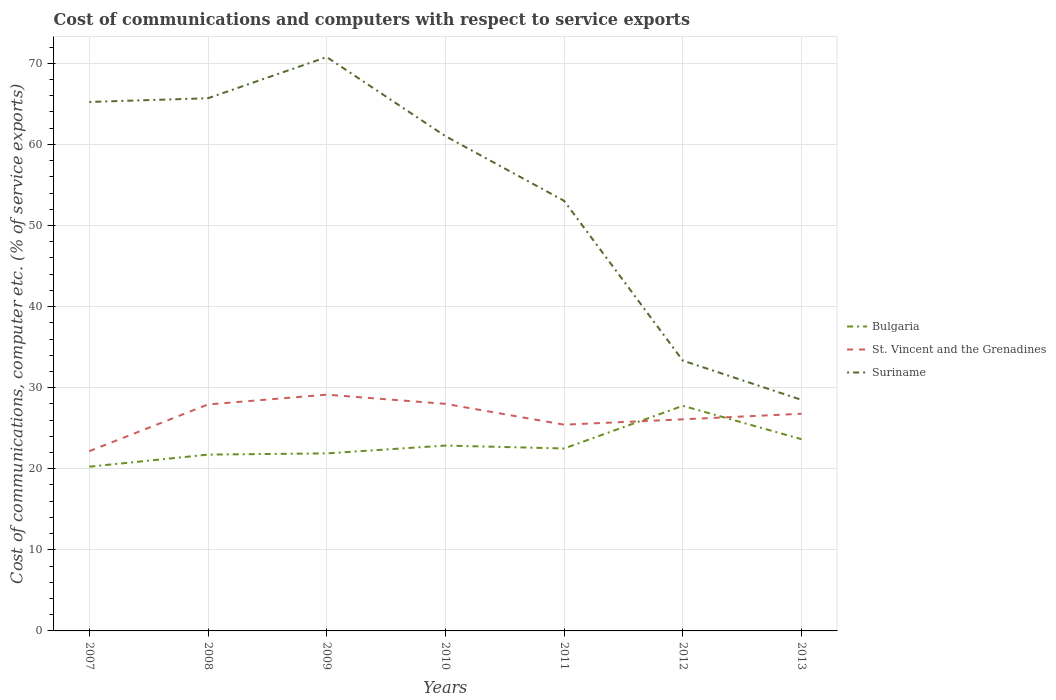How many different coloured lines are there?
Offer a very short reply. 3. Is the number of lines equal to the number of legend labels?
Make the answer very short. Yes. Across all years, what is the maximum cost of communications and computers in Suriname?
Your answer should be compact. 28.5. In which year was the cost of communications and computers in St. Vincent and the Grenadines maximum?
Your response must be concise. 2007. What is the total cost of communications and computers in St. Vincent and the Grenadines in the graph?
Offer a terse response. -5.83. What is the difference between the highest and the second highest cost of communications and computers in Suriname?
Ensure brevity in your answer.  42.27. What is the difference between the highest and the lowest cost of communications and computers in Suriname?
Give a very brief answer. 4. How many lines are there?
Your answer should be compact. 3. What is the difference between two consecutive major ticks on the Y-axis?
Your answer should be compact. 10. Where does the legend appear in the graph?
Provide a succinct answer. Center right. How many legend labels are there?
Offer a terse response. 3. What is the title of the graph?
Make the answer very short. Cost of communications and computers with respect to service exports. What is the label or title of the Y-axis?
Your answer should be compact. Cost of communications, computer etc. (% of service exports). What is the Cost of communications, computer etc. (% of service exports) of Bulgaria in 2007?
Your answer should be very brief. 20.25. What is the Cost of communications, computer etc. (% of service exports) of St. Vincent and the Grenadines in 2007?
Your response must be concise. 22.17. What is the Cost of communications, computer etc. (% of service exports) in Suriname in 2007?
Ensure brevity in your answer.  65.23. What is the Cost of communications, computer etc. (% of service exports) of Bulgaria in 2008?
Keep it short and to the point. 21.74. What is the Cost of communications, computer etc. (% of service exports) in St. Vincent and the Grenadines in 2008?
Keep it short and to the point. 27.93. What is the Cost of communications, computer etc. (% of service exports) of Suriname in 2008?
Your answer should be compact. 65.69. What is the Cost of communications, computer etc. (% of service exports) of Bulgaria in 2009?
Your answer should be compact. 21.89. What is the Cost of communications, computer etc. (% of service exports) in St. Vincent and the Grenadines in 2009?
Offer a very short reply. 29.14. What is the Cost of communications, computer etc. (% of service exports) of Suriname in 2009?
Your answer should be compact. 70.77. What is the Cost of communications, computer etc. (% of service exports) in Bulgaria in 2010?
Your answer should be compact. 22.86. What is the Cost of communications, computer etc. (% of service exports) in St. Vincent and the Grenadines in 2010?
Provide a succinct answer. 28. What is the Cost of communications, computer etc. (% of service exports) of Suriname in 2010?
Your response must be concise. 61.02. What is the Cost of communications, computer etc. (% of service exports) in Bulgaria in 2011?
Your response must be concise. 22.5. What is the Cost of communications, computer etc. (% of service exports) in St. Vincent and the Grenadines in 2011?
Ensure brevity in your answer.  25.43. What is the Cost of communications, computer etc. (% of service exports) of Suriname in 2011?
Your answer should be compact. 53.04. What is the Cost of communications, computer etc. (% of service exports) in Bulgaria in 2012?
Keep it short and to the point. 27.76. What is the Cost of communications, computer etc. (% of service exports) in St. Vincent and the Grenadines in 2012?
Provide a short and direct response. 26.09. What is the Cost of communications, computer etc. (% of service exports) in Suriname in 2012?
Your answer should be compact. 33.34. What is the Cost of communications, computer etc. (% of service exports) of Bulgaria in 2013?
Ensure brevity in your answer.  23.65. What is the Cost of communications, computer etc. (% of service exports) in St. Vincent and the Grenadines in 2013?
Provide a succinct answer. 26.78. What is the Cost of communications, computer etc. (% of service exports) of Suriname in 2013?
Provide a short and direct response. 28.5. Across all years, what is the maximum Cost of communications, computer etc. (% of service exports) of Bulgaria?
Offer a very short reply. 27.76. Across all years, what is the maximum Cost of communications, computer etc. (% of service exports) of St. Vincent and the Grenadines?
Provide a short and direct response. 29.14. Across all years, what is the maximum Cost of communications, computer etc. (% of service exports) of Suriname?
Provide a succinct answer. 70.77. Across all years, what is the minimum Cost of communications, computer etc. (% of service exports) of Bulgaria?
Offer a very short reply. 20.25. Across all years, what is the minimum Cost of communications, computer etc. (% of service exports) in St. Vincent and the Grenadines?
Provide a short and direct response. 22.17. Across all years, what is the minimum Cost of communications, computer etc. (% of service exports) of Suriname?
Your response must be concise. 28.5. What is the total Cost of communications, computer etc. (% of service exports) in Bulgaria in the graph?
Provide a succinct answer. 160.66. What is the total Cost of communications, computer etc. (% of service exports) of St. Vincent and the Grenadines in the graph?
Your answer should be very brief. 185.55. What is the total Cost of communications, computer etc. (% of service exports) in Suriname in the graph?
Keep it short and to the point. 377.59. What is the difference between the Cost of communications, computer etc. (% of service exports) of Bulgaria in 2007 and that in 2008?
Your response must be concise. -1.49. What is the difference between the Cost of communications, computer etc. (% of service exports) of St. Vincent and the Grenadines in 2007 and that in 2008?
Ensure brevity in your answer.  -5.76. What is the difference between the Cost of communications, computer etc. (% of service exports) of Suriname in 2007 and that in 2008?
Make the answer very short. -0.46. What is the difference between the Cost of communications, computer etc. (% of service exports) in Bulgaria in 2007 and that in 2009?
Ensure brevity in your answer.  -1.64. What is the difference between the Cost of communications, computer etc. (% of service exports) in St. Vincent and the Grenadines in 2007 and that in 2009?
Your answer should be very brief. -6.97. What is the difference between the Cost of communications, computer etc. (% of service exports) in Suriname in 2007 and that in 2009?
Offer a very short reply. -5.54. What is the difference between the Cost of communications, computer etc. (% of service exports) in Bulgaria in 2007 and that in 2010?
Your answer should be compact. -2.6. What is the difference between the Cost of communications, computer etc. (% of service exports) of St. Vincent and the Grenadines in 2007 and that in 2010?
Offer a very short reply. -5.83. What is the difference between the Cost of communications, computer etc. (% of service exports) of Suriname in 2007 and that in 2010?
Provide a succinct answer. 4.21. What is the difference between the Cost of communications, computer etc. (% of service exports) in Bulgaria in 2007 and that in 2011?
Your response must be concise. -2.24. What is the difference between the Cost of communications, computer etc. (% of service exports) of St. Vincent and the Grenadines in 2007 and that in 2011?
Offer a very short reply. -3.27. What is the difference between the Cost of communications, computer etc. (% of service exports) in Suriname in 2007 and that in 2011?
Give a very brief answer. 12.19. What is the difference between the Cost of communications, computer etc. (% of service exports) of Bulgaria in 2007 and that in 2012?
Make the answer very short. -7.51. What is the difference between the Cost of communications, computer etc. (% of service exports) of St. Vincent and the Grenadines in 2007 and that in 2012?
Offer a terse response. -3.92. What is the difference between the Cost of communications, computer etc. (% of service exports) in Suriname in 2007 and that in 2012?
Keep it short and to the point. 31.89. What is the difference between the Cost of communications, computer etc. (% of service exports) in Bulgaria in 2007 and that in 2013?
Offer a very short reply. -3.39. What is the difference between the Cost of communications, computer etc. (% of service exports) of St. Vincent and the Grenadines in 2007 and that in 2013?
Provide a succinct answer. -4.61. What is the difference between the Cost of communications, computer etc. (% of service exports) in Suriname in 2007 and that in 2013?
Your answer should be very brief. 36.74. What is the difference between the Cost of communications, computer etc. (% of service exports) in Bulgaria in 2008 and that in 2009?
Your answer should be very brief. -0.15. What is the difference between the Cost of communications, computer etc. (% of service exports) of St. Vincent and the Grenadines in 2008 and that in 2009?
Your answer should be compact. -1.21. What is the difference between the Cost of communications, computer etc. (% of service exports) of Suriname in 2008 and that in 2009?
Your response must be concise. -5.08. What is the difference between the Cost of communications, computer etc. (% of service exports) of Bulgaria in 2008 and that in 2010?
Offer a very short reply. -1.12. What is the difference between the Cost of communications, computer etc. (% of service exports) in St. Vincent and the Grenadines in 2008 and that in 2010?
Offer a terse response. -0.07. What is the difference between the Cost of communications, computer etc. (% of service exports) of Suriname in 2008 and that in 2010?
Keep it short and to the point. 4.67. What is the difference between the Cost of communications, computer etc. (% of service exports) in Bulgaria in 2008 and that in 2011?
Offer a very short reply. -0.76. What is the difference between the Cost of communications, computer etc. (% of service exports) in St. Vincent and the Grenadines in 2008 and that in 2011?
Keep it short and to the point. 2.5. What is the difference between the Cost of communications, computer etc. (% of service exports) of Suriname in 2008 and that in 2011?
Make the answer very short. 12.65. What is the difference between the Cost of communications, computer etc. (% of service exports) of Bulgaria in 2008 and that in 2012?
Offer a terse response. -6.02. What is the difference between the Cost of communications, computer etc. (% of service exports) in St. Vincent and the Grenadines in 2008 and that in 2012?
Keep it short and to the point. 1.84. What is the difference between the Cost of communications, computer etc. (% of service exports) in Suriname in 2008 and that in 2012?
Your answer should be compact. 32.36. What is the difference between the Cost of communications, computer etc. (% of service exports) in Bulgaria in 2008 and that in 2013?
Give a very brief answer. -1.9. What is the difference between the Cost of communications, computer etc. (% of service exports) of St. Vincent and the Grenadines in 2008 and that in 2013?
Make the answer very short. 1.15. What is the difference between the Cost of communications, computer etc. (% of service exports) in Suriname in 2008 and that in 2013?
Your answer should be very brief. 37.2. What is the difference between the Cost of communications, computer etc. (% of service exports) of Bulgaria in 2009 and that in 2010?
Give a very brief answer. -0.97. What is the difference between the Cost of communications, computer etc. (% of service exports) in St. Vincent and the Grenadines in 2009 and that in 2010?
Ensure brevity in your answer.  1.13. What is the difference between the Cost of communications, computer etc. (% of service exports) in Suriname in 2009 and that in 2010?
Offer a very short reply. 9.75. What is the difference between the Cost of communications, computer etc. (% of service exports) in Bulgaria in 2009 and that in 2011?
Offer a terse response. -0.6. What is the difference between the Cost of communications, computer etc. (% of service exports) of St. Vincent and the Grenadines in 2009 and that in 2011?
Offer a very short reply. 3.7. What is the difference between the Cost of communications, computer etc. (% of service exports) of Suriname in 2009 and that in 2011?
Give a very brief answer. 17.73. What is the difference between the Cost of communications, computer etc. (% of service exports) in Bulgaria in 2009 and that in 2012?
Provide a short and direct response. -5.87. What is the difference between the Cost of communications, computer etc. (% of service exports) of St. Vincent and the Grenadines in 2009 and that in 2012?
Offer a terse response. 3.04. What is the difference between the Cost of communications, computer etc. (% of service exports) in Suriname in 2009 and that in 2012?
Make the answer very short. 37.43. What is the difference between the Cost of communications, computer etc. (% of service exports) of Bulgaria in 2009 and that in 2013?
Provide a short and direct response. -1.75. What is the difference between the Cost of communications, computer etc. (% of service exports) in St. Vincent and the Grenadines in 2009 and that in 2013?
Your response must be concise. 2.35. What is the difference between the Cost of communications, computer etc. (% of service exports) in Suriname in 2009 and that in 2013?
Your response must be concise. 42.27. What is the difference between the Cost of communications, computer etc. (% of service exports) of Bulgaria in 2010 and that in 2011?
Your answer should be very brief. 0.36. What is the difference between the Cost of communications, computer etc. (% of service exports) of St. Vincent and the Grenadines in 2010 and that in 2011?
Keep it short and to the point. 2.57. What is the difference between the Cost of communications, computer etc. (% of service exports) in Suriname in 2010 and that in 2011?
Give a very brief answer. 7.98. What is the difference between the Cost of communications, computer etc. (% of service exports) of Bulgaria in 2010 and that in 2012?
Ensure brevity in your answer.  -4.9. What is the difference between the Cost of communications, computer etc. (% of service exports) of St. Vincent and the Grenadines in 2010 and that in 2012?
Ensure brevity in your answer.  1.91. What is the difference between the Cost of communications, computer etc. (% of service exports) of Suriname in 2010 and that in 2012?
Your response must be concise. 27.68. What is the difference between the Cost of communications, computer etc. (% of service exports) of Bulgaria in 2010 and that in 2013?
Your answer should be compact. -0.79. What is the difference between the Cost of communications, computer etc. (% of service exports) of St. Vincent and the Grenadines in 2010 and that in 2013?
Make the answer very short. 1.22. What is the difference between the Cost of communications, computer etc. (% of service exports) in Suriname in 2010 and that in 2013?
Make the answer very short. 32.52. What is the difference between the Cost of communications, computer etc. (% of service exports) in Bulgaria in 2011 and that in 2012?
Your answer should be compact. -5.26. What is the difference between the Cost of communications, computer etc. (% of service exports) in St. Vincent and the Grenadines in 2011 and that in 2012?
Provide a short and direct response. -0.66. What is the difference between the Cost of communications, computer etc. (% of service exports) of Suriname in 2011 and that in 2012?
Give a very brief answer. 19.7. What is the difference between the Cost of communications, computer etc. (% of service exports) in Bulgaria in 2011 and that in 2013?
Your response must be concise. -1.15. What is the difference between the Cost of communications, computer etc. (% of service exports) in St. Vincent and the Grenadines in 2011 and that in 2013?
Your answer should be compact. -1.35. What is the difference between the Cost of communications, computer etc. (% of service exports) in Suriname in 2011 and that in 2013?
Provide a short and direct response. 24.54. What is the difference between the Cost of communications, computer etc. (% of service exports) of Bulgaria in 2012 and that in 2013?
Your answer should be compact. 4.12. What is the difference between the Cost of communications, computer etc. (% of service exports) in St. Vincent and the Grenadines in 2012 and that in 2013?
Make the answer very short. -0.69. What is the difference between the Cost of communications, computer etc. (% of service exports) of Suriname in 2012 and that in 2013?
Offer a terse response. 4.84. What is the difference between the Cost of communications, computer etc. (% of service exports) of Bulgaria in 2007 and the Cost of communications, computer etc. (% of service exports) of St. Vincent and the Grenadines in 2008?
Make the answer very short. -7.67. What is the difference between the Cost of communications, computer etc. (% of service exports) of Bulgaria in 2007 and the Cost of communications, computer etc. (% of service exports) of Suriname in 2008?
Make the answer very short. -45.44. What is the difference between the Cost of communications, computer etc. (% of service exports) of St. Vincent and the Grenadines in 2007 and the Cost of communications, computer etc. (% of service exports) of Suriname in 2008?
Ensure brevity in your answer.  -43.52. What is the difference between the Cost of communications, computer etc. (% of service exports) of Bulgaria in 2007 and the Cost of communications, computer etc. (% of service exports) of St. Vincent and the Grenadines in 2009?
Give a very brief answer. -8.88. What is the difference between the Cost of communications, computer etc. (% of service exports) in Bulgaria in 2007 and the Cost of communications, computer etc. (% of service exports) in Suriname in 2009?
Your answer should be very brief. -50.52. What is the difference between the Cost of communications, computer etc. (% of service exports) in St. Vincent and the Grenadines in 2007 and the Cost of communications, computer etc. (% of service exports) in Suriname in 2009?
Keep it short and to the point. -48.6. What is the difference between the Cost of communications, computer etc. (% of service exports) of Bulgaria in 2007 and the Cost of communications, computer etc. (% of service exports) of St. Vincent and the Grenadines in 2010?
Make the answer very short. -7.75. What is the difference between the Cost of communications, computer etc. (% of service exports) in Bulgaria in 2007 and the Cost of communications, computer etc. (% of service exports) in Suriname in 2010?
Offer a terse response. -40.76. What is the difference between the Cost of communications, computer etc. (% of service exports) of St. Vincent and the Grenadines in 2007 and the Cost of communications, computer etc. (% of service exports) of Suriname in 2010?
Provide a short and direct response. -38.85. What is the difference between the Cost of communications, computer etc. (% of service exports) of Bulgaria in 2007 and the Cost of communications, computer etc. (% of service exports) of St. Vincent and the Grenadines in 2011?
Your response must be concise. -5.18. What is the difference between the Cost of communications, computer etc. (% of service exports) in Bulgaria in 2007 and the Cost of communications, computer etc. (% of service exports) in Suriname in 2011?
Your response must be concise. -32.79. What is the difference between the Cost of communications, computer etc. (% of service exports) in St. Vincent and the Grenadines in 2007 and the Cost of communications, computer etc. (% of service exports) in Suriname in 2011?
Offer a very short reply. -30.87. What is the difference between the Cost of communications, computer etc. (% of service exports) in Bulgaria in 2007 and the Cost of communications, computer etc. (% of service exports) in St. Vincent and the Grenadines in 2012?
Offer a very short reply. -5.84. What is the difference between the Cost of communications, computer etc. (% of service exports) of Bulgaria in 2007 and the Cost of communications, computer etc. (% of service exports) of Suriname in 2012?
Make the answer very short. -13.08. What is the difference between the Cost of communications, computer etc. (% of service exports) of St. Vincent and the Grenadines in 2007 and the Cost of communications, computer etc. (% of service exports) of Suriname in 2012?
Ensure brevity in your answer.  -11.17. What is the difference between the Cost of communications, computer etc. (% of service exports) of Bulgaria in 2007 and the Cost of communications, computer etc. (% of service exports) of St. Vincent and the Grenadines in 2013?
Ensure brevity in your answer.  -6.53. What is the difference between the Cost of communications, computer etc. (% of service exports) of Bulgaria in 2007 and the Cost of communications, computer etc. (% of service exports) of Suriname in 2013?
Your answer should be very brief. -8.24. What is the difference between the Cost of communications, computer etc. (% of service exports) of St. Vincent and the Grenadines in 2007 and the Cost of communications, computer etc. (% of service exports) of Suriname in 2013?
Offer a very short reply. -6.33. What is the difference between the Cost of communications, computer etc. (% of service exports) in Bulgaria in 2008 and the Cost of communications, computer etc. (% of service exports) in St. Vincent and the Grenadines in 2009?
Make the answer very short. -7.39. What is the difference between the Cost of communications, computer etc. (% of service exports) of Bulgaria in 2008 and the Cost of communications, computer etc. (% of service exports) of Suriname in 2009?
Keep it short and to the point. -49.03. What is the difference between the Cost of communications, computer etc. (% of service exports) of St. Vincent and the Grenadines in 2008 and the Cost of communications, computer etc. (% of service exports) of Suriname in 2009?
Offer a terse response. -42.84. What is the difference between the Cost of communications, computer etc. (% of service exports) of Bulgaria in 2008 and the Cost of communications, computer etc. (% of service exports) of St. Vincent and the Grenadines in 2010?
Offer a very short reply. -6.26. What is the difference between the Cost of communications, computer etc. (% of service exports) of Bulgaria in 2008 and the Cost of communications, computer etc. (% of service exports) of Suriname in 2010?
Keep it short and to the point. -39.28. What is the difference between the Cost of communications, computer etc. (% of service exports) of St. Vincent and the Grenadines in 2008 and the Cost of communications, computer etc. (% of service exports) of Suriname in 2010?
Provide a succinct answer. -33.09. What is the difference between the Cost of communications, computer etc. (% of service exports) in Bulgaria in 2008 and the Cost of communications, computer etc. (% of service exports) in St. Vincent and the Grenadines in 2011?
Make the answer very short. -3.69. What is the difference between the Cost of communications, computer etc. (% of service exports) of Bulgaria in 2008 and the Cost of communications, computer etc. (% of service exports) of Suriname in 2011?
Make the answer very short. -31.3. What is the difference between the Cost of communications, computer etc. (% of service exports) of St. Vincent and the Grenadines in 2008 and the Cost of communications, computer etc. (% of service exports) of Suriname in 2011?
Offer a terse response. -25.11. What is the difference between the Cost of communications, computer etc. (% of service exports) of Bulgaria in 2008 and the Cost of communications, computer etc. (% of service exports) of St. Vincent and the Grenadines in 2012?
Keep it short and to the point. -4.35. What is the difference between the Cost of communications, computer etc. (% of service exports) of Bulgaria in 2008 and the Cost of communications, computer etc. (% of service exports) of Suriname in 2012?
Your response must be concise. -11.59. What is the difference between the Cost of communications, computer etc. (% of service exports) of St. Vincent and the Grenadines in 2008 and the Cost of communications, computer etc. (% of service exports) of Suriname in 2012?
Your answer should be very brief. -5.41. What is the difference between the Cost of communications, computer etc. (% of service exports) in Bulgaria in 2008 and the Cost of communications, computer etc. (% of service exports) in St. Vincent and the Grenadines in 2013?
Offer a very short reply. -5.04. What is the difference between the Cost of communications, computer etc. (% of service exports) in Bulgaria in 2008 and the Cost of communications, computer etc. (% of service exports) in Suriname in 2013?
Give a very brief answer. -6.75. What is the difference between the Cost of communications, computer etc. (% of service exports) in St. Vincent and the Grenadines in 2008 and the Cost of communications, computer etc. (% of service exports) in Suriname in 2013?
Provide a succinct answer. -0.57. What is the difference between the Cost of communications, computer etc. (% of service exports) of Bulgaria in 2009 and the Cost of communications, computer etc. (% of service exports) of St. Vincent and the Grenadines in 2010?
Provide a short and direct response. -6.11. What is the difference between the Cost of communications, computer etc. (% of service exports) in Bulgaria in 2009 and the Cost of communications, computer etc. (% of service exports) in Suriname in 2010?
Keep it short and to the point. -39.12. What is the difference between the Cost of communications, computer etc. (% of service exports) of St. Vincent and the Grenadines in 2009 and the Cost of communications, computer etc. (% of service exports) of Suriname in 2010?
Your response must be concise. -31.88. What is the difference between the Cost of communications, computer etc. (% of service exports) in Bulgaria in 2009 and the Cost of communications, computer etc. (% of service exports) in St. Vincent and the Grenadines in 2011?
Offer a terse response. -3.54. What is the difference between the Cost of communications, computer etc. (% of service exports) in Bulgaria in 2009 and the Cost of communications, computer etc. (% of service exports) in Suriname in 2011?
Ensure brevity in your answer.  -31.15. What is the difference between the Cost of communications, computer etc. (% of service exports) in St. Vincent and the Grenadines in 2009 and the Cost of communications, computer etc. (% of service exports) in Suriname in 2011?
Provide a short and direct response. -23.91. What is the difference between the Cost of communications, computer etc. (% of service exports) of Bulgaria in 2009 and the Cost of communications, computer etc. (% of service exports) of St. Vincent and the Grenadines in 2012?
Offer a very short reply. -4.2. What is the difference between the Cost of communications, computer etc. (% of service exports) in Bulgaria in 2009 and the Cost of communications, computer etc. (% of service exports) in Suriname in 2012?
Ensure brevity in your answer.  -11.44. What is the difference between the Cost of communications, computer etc. (% of service exports) of St. Vincent and the Grenadines in 2009 and the Cost of communications, computer etc. (% of service exports) of Suriname in 2012?
Your answer should be compact. -4.2. What is the difference between the Cost of communications, computer etc. (% of service exports) of Bulgaria in 2009 and the Cost of communications, computer etc. (% of service exports) of St. Vincent and the Grenadines in 2013?
Your answer should be very brief. -4.89. What is the difference between the Cost of communications, computer etc. (% of service exports) of Bulgaria in 2009 and the Cost of communications, computer etc. (% of service exports) of Suriname in 2013?
Offer a very short reply. -6.6. What is the difference between the Cost of communications, computer etc. (% of service exports) of St. Vincent and the Grenadines in 2009 and the Cost of communications, computer etc. (% of service exports) of Suriname in 2013?
Offer a terse response. 0.64. What is the difference between the Cost of communications, computer etc. (% of service exports) of Bulgaria in 2010 and the Cost of communications, computer etc. (% of service exports) of St. Vincent and the Grenadines in 2011?
Keep it short and to the point. -2.57. What is the difference between the Cost of communications, computer etc. (% of service exports) in Bulgaria in 2010 and the Cost of communications, computer etc. (% of service exports) in Suriname in 2011?
Your answer should be compact. -30.18. What is the difference between the Cost of communications, computer etc. (% of service exports) of St. Vincent and the Grenadines in 2010 and the Cost of communications, computer etc. (% of service exports) of Suriname in 2011?
Offer a very short reply. -25.04. What is the difference between the Cost of communications, computer etc. (% of service exports) of Bulgaria in 2010 and the Cost of communications, computer etc. (% of service exports) of St. Vincent and the Grenadines in 2012?
Your response must be concise. -3.23. What is the difference between the Cost of communications, computer etc. (% of service exports) in Bulgaria in 2010 and the Cost of communications, computer etc. (% of service exports) in Suriname in 2012?
Your answer should be very brief. -10.48. What is the difference between the Cost of communications, computer etc. (% of service exports) of St. Vincent and the Grenadines in 2010 and the Cost of communications, computer etc. (% of service exports) of Suriname in 2012?
Provide a succinct answer. -5.33. What is the difference between the Cost of communications, computer etc. (% of service exports) of Bulgaria in 2010 and the Cost of communications, computer etc. (% of service exports) of St. Vincent and the Grenadines in 2013?
Offer a very short reply. -3.92. What is the difference between the Cost of communications, computer etc. (% of service exports) in Bulgaria in 2010 and the Cost of communications, computer etc. (% of service exports) in Suriname in 2013?
Ensure brevity in your answer.  -5.64. What is the difference between the Cost of communications, computer etc. (% of service exports) of St. Vincent and the Grenadines in 2010 and the Cost of communications, computer etc. (% of service exports) of Suriname in 2013?
Offer a terse response. -0.49. What is the difference between the Cost of communications, computer etc. (% of service exports) of Bulgaria in 2011 and the Cost of communications, computer etc. (% of service exports) of St. Vincent and the Grenadines in 2012?
Ensure brevity in your answer.  -3.59. What is the difference between the Cost of communications, computer etc. (% of service exports) in Bulgaria in 2011 and the Cost of communications, computer etc. (% of service exports) in Suriname in 2012?
Your answer should be very brief. -10.84. What is the difference between the Cost of communications, computer etc. (% of service exports) of St. Vincent and the Grenadines in 2011 and the Cost of communications, computer etc. (% of service exports) of Suriname in 2012?
Your answer should be compact. -7.9. What is the difference between the Cost of communications, computer etc. (% of service exports) in Bulgaria in 2011 and the Cost of communications, computer etc. (% of service exports) in St. Vincent and the Grenadines in 2013?
Your response must be concise. -4.28. What is the difference between the Cost of communications, computer etc. (% of service exports) in Bulgaria in 2011 and the Cost of communications, computer etc. (% of service exports) in Suriname in 2013?
Your answer should be very brief. -6. What is the difference between the Cost of communications, computer etc. (% of service exports) of St. Vincent and the Grenadines in 2011 and the Cost of communications, computer etc. (% of service exports) of Suriname in 2013?
Offer a terse response. -3.06. What is the difference between the Cost of communications, computer etc. (% of service exports) in Bulgaria in 2012 and the Cost of communications, computer etc. (% of service exports) in St. Vincent and the Grenadines in 2013?
Offer a very short reply. 0.98. What is the difference between the Cost of communications, computer etc. (% of service exports) of Bulgaria in 2012 and the Cost of communications, computer etc. (% of service exports) of Suriname in 2013?
Make the answer very short. -0.74. What is the difference between the Cost of communications, computer etc. (% of service exports) of St. Vincent and the Grenadines in 2012 and the Cost of communications, computer etc. (% of service exports) of Suriname in 2013?
Make the answer very short. -2.4. What is the average Cost of communications, computer etc. (% of service exports) of Bulgaria per year?
Ensure brevity in your answer.  22.95. What is the average Cost of communications, computer etc. (% of service exports) in St. Vincent and the Grenadines per year?
Give a very brief answer. 26.51. What is the average Cost of communications, computer etc. (% of service exports) in Suriname per year?
Your answer should be very brief. 53.94. In the year 2007, what is the difference between the Cost of communications, computer etc. (% of service exports) in Bulgaria and Cost of communications, computer etc. (% of service exports) in St. Vincent and the Grenadines?
Provide a short and direct response. -1.91. In the year 2007, what is the difference between the Cost of communications, computer etc. (% of service exports) in Bulgaria and Cost of communications, computer etc. (% of service exports) in Suriname?
Give a very brief answer. -44.98. In the year 2007, what is the difference between the Cost of communications, computer etc. (% of service exports) in St. Vincent and the Grenadines and Cost of communications, computer etc. (% of service exports) in Suriname?
Keep it short and to the point. -43.06. In the year 2008, what is the difference between the Cost of communications, computer etc. (% of service exports) of Bulgaria and Cost of communications, computer etc. (% of service exports) of St. Vincent and the Grenadines?
Your answer should be compact. -6.19. In the year 2008, what is the difference between the Cost of communications, computer etc. (% of service exports) in Bulgaria and Cost of communications, computer etc. (% of service exports) in Suriname?
Make the answer very short. -43.95. In the year 2008, what is the difference between the Cost of communications, computer etc. (% of service exports) in St. Vincent and the Grenadines and Cost of communications, computer etc. (% of service exports) in Suriname?
Offer a very short reply. -37.76. In the year 2009, what is the difference between the Cost of communications, computer etc. (% of service exports) in Bulgaria and Cost of communications, computer etc. (% of service exports) in St. Vincent and the Grenadines?
Make the answer very short. -7.24. In the year 2009, what is the difference between the Cost of communications, computer etc. (% of service exports) in Bulgaria and Cost of communications, computer etc. (% of service exports) in Suriname?
Your answer should be very brief. -48.88. In the year 2009, what is the difference between the Cost of communications, computer etc. (% of service exports) of St. Vincent and the Grenadines and Cost of communications, computer etc. (% of service exports) of Suriname?
Provide a short and direct response. -41.64. In the year 2010, what is the difference between the Cost of communications, computer etc. (% of service exports) in Bulgaria and Cost of communications, computer etc. (% of service exports) in St. Vincent and the Grenadines?
Keep it short and to the point. -5.14. In the year 2010, what is the difference between the Cost of communications, computer etc. (% of service exports) in Bulgaria and Cost of communications, computer etc. (% of service exports) in Suriname?
Your response must be concise. -38.16. In the year 2010, what is the difference between the Cost of communications, computer etc. (% of service exports) in St. Vincent and the Grenadines and Cost of communications, computer etc. (% of service exports) in Suriname?
Your answer should be very brief. -33.02. In the year 2011, what is the difference between the Cost of communications, computer etc. (% of service exports) of Bulgaria and Cost of communications, computer etc. (% of service exports) of St. Vincent and the Grenadines?
Ensure brevity in your answer.  -2.94. In the year 2011, what is the difference between the Cost of communications, computer etc. (% of service exports) of Bulgaria and Cost of communications, computer etc. (% of service exports) of Suriname?
Your answer should be compact. -30.54. In the year 2011, what is the difference between the Cost of communications, computer etc. (% of service exports) in St. Vincent and the Grenadines and Cost of communications, computer etc. (% of service exports) in Suriname?
Provide a short and direct response. -27.61. In the year 2012, what is the difference between the Cost of communications, computer etc. (% of service exports) of Bulgaria and Cost of communications, computer etc. (% of service exports) of St. Vincent and the Grenadines?
Offer a very short reply. 1.67. In the year 2012, what is the difference between the Cost of communications, computer etc. (% of service exports) in Bulgaria and Cost of communications, computer etc. (% of service exports) in Suriname?
Provide a short and direct response. -5.58. In the year 2012, what is the difference between the Cost of communications, computer etc. (% of service exports) of St. Vincent and the Grenadines and Cost of communications, computer etc. (% of service exports) of Suriname?
Your response must be concise. -7.25. In the year 2013, what is the difference between the Cost of communications, computer etc. (% of service exports) in Bulgaria and Cost of communications, computer etc. (% of service exports) in St. Vincent and the Grenadines?
Ensure brevity in your answer.  -3.14. In the year 2013, what is the difference between the Cost of communications, computer etc. (% of service exports) in Bulgaria and Cost of communications, computer etc. (% of service exports) in Suriname?
Keep it short and to the point. -4.85. In the year 2013, what is the difference between the Cost of communications, computer etc. (% of service exports) of St. Vincent and the Grenadines and Cost of communications, computer etc. (% of service exports) of Suriname?
Make the answer very short. -1.71. What is the ratio of the Cost of communications, computer etc. (% of service exports) of Bulgaria in 2007 to that in 2008?
Provide a succinct answer. 0.93. What is the ratio of the Cost of communications, computer etc. (% of service exports) of St. Vincent and the Grenadines in 2007 to that in 2008?
Your answer should be very brief. 0.79. What is the ratio of the Cost of communications, computer etc. (% of service exports) of Bulgaria in 2007 to that in 2009?
Your response must be concise. 0.93. What is the ratio of the Cost of communications, computer etc. (% of service exports) of St. Vincent and the Grenadines in 2007 to that in 2009?
Ensure brevity in your answer.  0.76. What is the ratio of the Cost of communications, computer etc. (% of service exports) of Suriname in 2007 to that in 2009?
Provide a short and direct response. 0.92. What is the ratio of the Cost of communications, computer etc. (% of service exports) of Bulgaria in 2007 to that in 2010?
Give a very brief answer. 0.89. What is the ratio of the Cost of communications, computer etc. (% of service exports) of St. Vincent and the Grenadines in 2007 to that in 2010?
Provide a succinct answer. 0.79. What is the ratio of the Cost of communications, computer etc. (% of service exports) in Suriname in 2007 to that in 2010?
Provide a succinct answer. 1.07. What is the ratio of the Cost of communications, computer etc. (% of service exports) in Bulgaria in 2007 to that in 2011?
Provide a short and direct response. 0.9. What is the ratio of the Cost of communications, computer etc. (% of service exports) in St. Vincent and the Grenadines in 2007 to that in 2011?
Offer a very short reply. 0.87. What is the ratio of the Cost of communications, computer etc. (% of service exports) of Suriname in 2007 to that in 2011?
Give a very brief answer. 1.23. What is the ratio of the Cost of communications, computer etc. (% of service exports) of Bulgaria in 2007 to that in 2012?
Provide a short and direct response. 0.73. What is the ratio of the Cost of communications, computer etc. (% of service exports) in St. Vincent and the Grenadines in 2007 to that in 2012?
Offer a terse response. 0.85. What is the ratio of the Cost of communications, computer etc. (% of service exports) in Suriname in 2007 to that in 2012?
Your answer should be very brief. 1.96. What is the ratio of the Cost of communications, computer etc. (% of service exports) in Bulgaria in 2007 to that in 2013?
Ensure brevity in your answer.  0.86. What is the ratio of the Cost of communications, computer etc. (% of service exports) of St. Vincent and the Grenadines in 2007 to that in 2013?
Provide a short and direct response. 0.83. What is the ratio of the Cost of communications, computer etc. (% of service exports) of Suriname in 2007 to that in 2013?
Ensure brevity in your answer.  2.29. What is the ratio of the Cost of communications, computer etc. (% of service exports) in St. Vincent and the Grenadines in 2008 to that in 2009?
Offer a terse response. 0.96. What is the ratio of the Cost of communications, computer etc. (% of service exports) of Suriname in 2008 to that in 2009?
Give a very brief answer. 0.93. What is the ratio of the Cost of communications, computer etc. (% of service exports) of Bulgaria in 2008 to that in 2010?
Provide a short and direct response. 0.95. What is the ratio of the Cost of communications, computer etc. (% of service exports) in St. Vincent and the Grenadines in 2008 to that in 2010?
Give a very brief answer. 1. What is the ratio of the Cost of communications, computer etc. (% of service exports) in Suriname in 2008 to that in 2010?
Your response must be concise. 1.08. What is the ratio of the Cost of communications, computer etc. (% of service exports) of Bulgaria in 2008 to that in 2011?
Provide a short and direct response. 0.97. What is the ratio of the Cost of communications, computer etc. (% of service exports) in St. Vincent and the Grenadines in 2008 to that in 2011?
Make the answer very short. 1.1. What is the ratio of the Cost of communications, computer etc. (% of service exports) of Suriname in 2008 to that in 2011?
Make the answer very short. 1.24. What is the ratio of the Cost of communications, computer etc. (% of service exports) of Bulgaria in 2008 to that in 2012?
Your answer should be compact. 0.78. What is the ratio of the Cost of communications, computer etc. (% of service exports) in St. Vincent and the Grenadines in 2008 to that in 2012?
Your answer should be very brief. 1.07. What is the ratio of the Cost of communications, computer etc. (% of service exports) of Suriname in 2008 to that in 2012?
Make the answer very short. 1.97. What is the ratio of the Cost of communications, computer etc. (% of service exports) of Bulgaria in 2008 to that in 2013?
Provide a short and direct response. 0.92. What is the ratio of the Cost of communications, computer etc. (% of service exports) of St. Vincent and the Grenadines in 2008 to that in 2013?
Ensure brevity in your answer.  1.04. What is the ratio of the Cost of communications, computer etc. (% of service exports) of Suriname in 2008 to that in 2013?
Ensure brevity in your answer.  2.31. What is the ratio of the Cost of communications, computer etc. (% of service exports) in Bulgaria in 2009 to that in 2010?
Provide a short and direct response. 0.96. What is the ratio of the Cost of communications, computer etc. (% of service exports) in St. Vincent and the Grenadines in 2009 to that in 2010?
Offer a terse response. 1.04. What is the ratio of the Cost of communications, computer etc. (% of service exports) of Suriname in 2009 to that in 2010?
Your answer should be compact. 1.16. What is the ratio of the Cost of communications, computer etc. (% of service exports) of Bulgaria in 2009 to that in 2011?
Make the answer very short. 0.97. What is the ratio of the Cost of communications, computer etc. (% of service exports) in St. Vincent and the Grenadines in 2009 to that in 2011?
Your response must be concise. 1.15. What is the ratio of the Cost of communications, computer etc. (% of service exports) in Suriname in 2009 to that in 2011?
Provide a short and direct response. 1.33. What is the ratio of the Cost of communications, computer etc. (% of service exports) of Bulgaria in 2009 to that in 2012?
Ensure brevity in your answer.  0.79. What is the ratio of the Cost of communications, computer etc. (% of service exports) in St. Vincent and the Grenadines in 2009 to that in 2012?
Provide a short and direct response. 1.12. What is the ratio of the Cost of communications, computer etc. (% of service exports) in Suriname in 2009 to that in 2012?
Your answer should be very brief. 2.12. What is the ratio of the Cost of communications, computer etc. (% of service exports) in Bulgaria in 2009 to that in 2013?
Your answer should be compact. 0.93. What is the ratio of the Cost of communications, computer etc. (% of service exports) of St. Vincent and the Grenadines in 2009 to that in 2013?
Your response must be concise. 1.09. What is the ratio of the Cost of communications, computer etc. (% of service exports) in Suriname in 2009 to that in 2013?
Ensure brevity in your answer.  2.48. What is the ratio of the Cost of communications, computer etc. (% of service exports) in St. Vincent and the Grenadines in 2010 to that in 2011?
Offer a terse response. 1.1. What is the ratio of the Cost of communications, computer etc. (% of service exports) of Suriname in 2010 to that in 2011?
Provide a succinct answer. 1.15. What is the ratio of the Cost of communications, computer etc. (% of service exports) in Bulgaria in 2010 to that in 2012?
Give a very brief answer. 0.82. What is the ratio of the Cost of communications, computer etc. (% of service exports) in St. Vincent and the Grenadines in 2010 to that in 2012?
Provide a short and direct response. 1.07. What is the ratio of the Cost of communications, computer etc. (% of service exports) of Suriname in 2010 to that in 2012?
Keep it short and to the point. 1.83. What is the ratio of the Cost of communications, computer etc. (% of service exports) in Bulgaria in 2010 to that in 2013?
Your answer should be compact. 0.97. What is the ratio of the Cost of communications, computer etc. (% of service exports) of St. Vincent and the Grenadines in 2010 to that in 2013?
Offer a very short reply. 1.05. What is the ratio of the Cost of communications, computer etc. (% of service exports) in Suriname in 2010 to that in 2013?
Provide a short and direct response. 2.14. What is the ratio of the Cost of communications, computer etc. (% of service exports) in Bulgaria in 2011 to that in 2012?
Make the answer very short. 0.81. What is the ratio of the Cost of communications, computer etc. (% of service exports) in St. Vincent and the Grenadines in 2011 to that in 2012?
Give a very brief answer. 0.97. What is the ratio of the Cost of communications, computer etc. (% of service exports) in Suriname in 2011 to that in 2012?
Ensure brevity in your answer.  1.59. What is the ratio of the Cost of communications, computer etc. (% of service exports) of Bulgaria in 2011 to that in 2013?
Give a very brief answer. 0.95. What is the ratio of the Cost of communications, computer etc. (% of service exports) of St. Vincent and the Grenadines in 2011 to that in 2013?
Make the answer very short. 0.95. What is the ratio of the Cost of communications, computer etc. (% of service exports) of Suriname in 2011 to that in 2013?
Your answer should be compact. 1.86. What is the ratio of the Cost of communications, computer etc. (% of service exports) of Bulgaria in 2012 to that in 2013?
Ensure brevity in your answer.  1.17. What is the ratio of the Cost of communications, computer etc. (% of service exports) in St. Vincent and the Grenadines in 2012 to that in 2013?
Your answer should be very brief. 0.97. What is the ratio of the Cost of communications, computer etc. (% of service exports) of Suriname in 2012 to that in 2013?
Provide a short and direct response. 1.17. What is the difference between the highest and the second highest Cost of communications, computer etc. (% of service exports) in Bulgaria?
Offer a terse response. 4.12. What is the difference between the highest and the second highest Cost of communications, computer etc. (% of service exports) of St. Vincent and the Grenadines?
Your response must be concise. 1.13. What is the difference between the highest and the second highest Cost of communications, computer etc. (% of service exports) in Suriname?
Provide a short and direct response. 5.08. What is the difference between the highest and the lowest Cost of communications, computer etc. (% of service exports) of Bulgaria?
Make the answer very short. 7.51. What is the difference between the highest and the lowest Cost of communications, computer etc. (% of service exports) in St. Vincent and the Grenadines?
Your answer should be compact. 6.97. What is the difference between the highest and the lowest Cost of communications, computer etc. (% of service exports) in Suriname?
Provide a short and direct response. 42.27. 